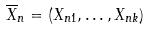<formula> <loc_0><loc_0><loc_500><loc_500>\overline { X } _ { n } = ( X _ { n 1 } , \dots , X _ { n k } )</formula> 